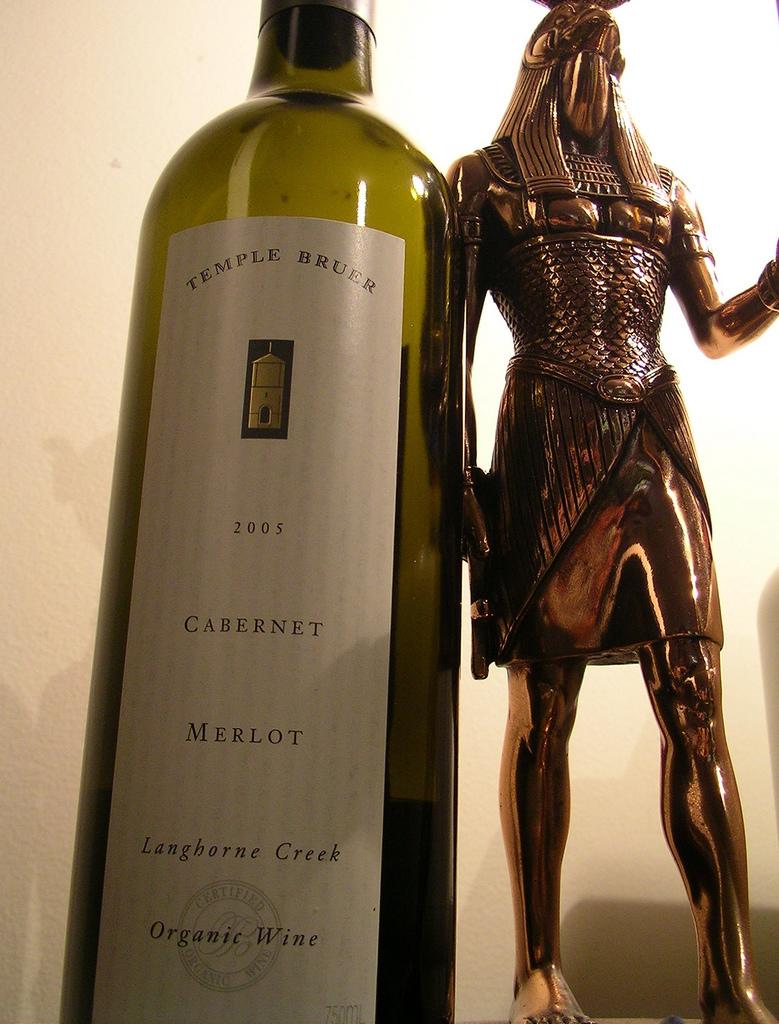What year wine is this?
Give a very brief answer. 2005. 